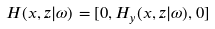Convert formula to latex. <formula><loc_0><loc_0><loc_500><loc_500>\, \ { H } ( x , z | \omega ) = [ 0 , H _ { y } ( x , z | \omega ) , 0 ]</formula> 